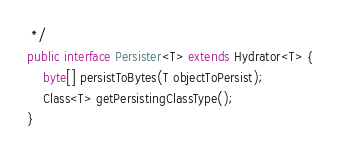Convert code to text. <code><loc_0><loc_0><loc_500><loc_500><_Java_> */
public interface Persister<T> extends Hydrator<T> {
    byte[] persistToBytes(T objectToPersist);
    Class<T> getPersistingClassType();
}
</code> 